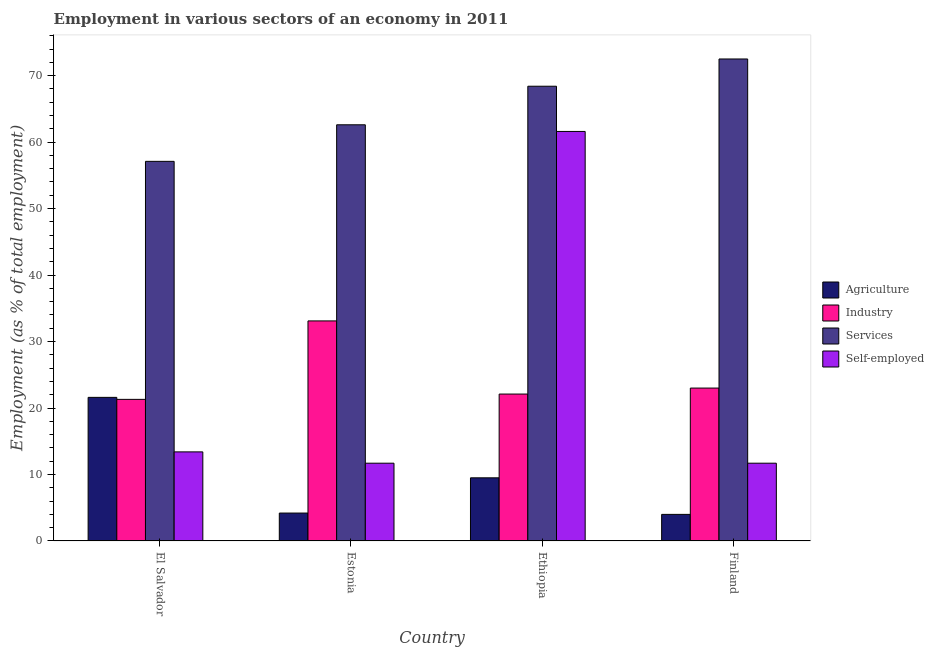How many different coloured bars are there?
Give a very brief answer. 4. How many groups of bars are there?
Provide a short and direct response. 4. Are the number of bars per tick equal to the number of legend labels?
Your answer should be compact. Yes. How many bars are there on the 3rd tick from the left?
Your answer should be very brief. 4. How many bars are there on the 2nd tick from the right?
Give a very brief answer. 4. What is the label of the 2nd group of bars from the left?
Offer a terse response. Estonia. In how many cases, is the number of bars for a given country not equal to the number of legend labels?
Your answer should be compact. 0. What is the percentage of workers in industry in El Salvador?
Provide a short and direct response. 21.3. Across all countries, what is the maximum percentage of workers in industry?
Give a very brief answer. 33.1. Across all countries, what is the minimum percentage of workers in industry?
Offer a very short reply. 21.3. In which country was the percentage of workers in services minimum?
Your response must be concise. El Salvador. What is the total percentage of workers in agriculture in the graph?
Ensure brevity in your answer.  39.3. What is the difference between the percentage of workers in industry in El Salvador and that in Estonia?
Give a very brief answer. -11.8. What is the difference between the percentage of workers in industry in El Salvador and the percentage of workers in services in Ethiopia?
Offer a terse response. -47.1. What is the average percentage of self employed workers per country?
Provide a short and direct response. 24.6. What is the difference between the percentage of workers in services and percentage of workers in agriculture in El Salvador?
Your answer should be very brief. 35.5. In how many countries, is the percentage of workers in agriculture greater than 18 %?
Provide a succinct answer. 1. What is the ratio of the percentage of self employed workers in Ethiopia to that in Finland?
Offer a terse response. 5.26. Is the percentage of workers in industry in El Salvador less than that in Finland?
Your response must be concise. Yes. What is the difference between the highest and the second highest percentage of workers in industry?
Offer a very short reply. 10.1. What is the difference between the highest and the lowest percentage of workers in agriculture?
Offer a terse response. 17.6. What does the 3rd bar from the left in Estonia represents?
Provide a succinct answer. Services. What does the 2nd bar from the right in Estonia represents?
Offer a terse response. Services. Are all the bars in the graph horizontal?
Give a very brief answer. No. What is the difference between two consecutive major ticks on the Y-axis?
Make the answer very short. 10. Are the values on the major ticks of Y-axis written in scientific E-notation?
Offer a very short reply. No. Does the graph contain any zero values?
Make the answer very short. No. Does the graph contain grids?
Offer a terse response. No. Where does the legend appear in the graph?
Ensure brevity in your answer.  Center right. What is the title of the graph?
Your answer should be compact. Employment in various sectors of an economy in 2011. Does "Burnt food" appear as one of the legend labels in the graph?
Keep it short and to the point. No. What is the label or title of the X-axis?
Your answer should be very brief. Country. What is the label or title of the Y-axis?
Your answer should be very brief. Employment (as % of total employment). What is the Employment (as % of total employment) in Agriculture in El Salvador?
Give a very brief answer. 21.6. What is the Employment (as % of total employment) of Industry in El Salvador?
Your response must be concise. 21.3. What is the Employment (as % of total employment) in Services in El Salvador?
Offer a very short reply. 57.1. What is the Employment (as % of total employment) of Self-employed in El Salvador?
Ensure brevity in your answer.  13.4. What is the Employment (as % of total employment) in Agriculture in Estonia?
Your answer should be compact. 4.2. What is the Employment (as % of total employment) in Industry in Estonia?
Your answer should be very brief. 33.1. What is the Employment (as % of total employment) of Services in Estonia?
Make the answer very short. 62.6. What is the Employment (as % of total employment) in Self-employed in Estonia?
Provide a succinct answer. 11.7. What is the Employment (as % of total employment) of Industry in Ethiopia?
Provide a succinct answer. 22.1. What is the Employment (as % of total employment) of Services in Ethiopia?
Your answer should be compact. 68.4. What is the Employment (as % of total employment) in Self-employed in Ethiopia?
Offer a very short reply. 61.6. What is the Employment (as % of total employment) in Agriculture in Finland?
Ensure brevity in your answer.  4. What is the Employment (as % of total employment) in Industry in Finland?
Ensure brevity in your answer.  23. What is the Employment (as % of total employment) in Services in Finland?
Offer a terse response. 72.5. What is the Employment (as % of total employment) of Self-employed in Finland?
Offer a terse response. 11.7. Across all countries, what is the maximum Employment (as % of total employment) of Agriculture?
Offer a terse response. 21.6. Across all countries, what is the maximum Employment (as % of total employment) in Industry?
Offer a terse response. 33.1. Across all countries, what is the maximum Employment (as % of total employment) of Services?
Offer a terse response. 72.5. Across all countries, what is the maximum Employment (as % of total employment) of Self-employed?
Offer a terse response. 61.6. Across all countries, what is the minimum Employment (as % of total employment) of Agriculture?
Provide a short and direct response. 4. Across all countries, what is the minimum Employment (as % of total employment) in Industry?
Provide a short and direct response. 21.3. Across all countries, what is the minimum Employment (as % of total employment) of Services?
Your answer should be compact. 57.1. Across all countries, what is the minimum Employment (as % of total employment) of Self-employed?
Ensure brevity in your answer.  11.7. What is the total Employment (as % of total employment) of Agriculture in the graph?
Ensure brevity in your answer.  39.3. What is the total Employment (as % of total employment) of Industry in the graph?
Offer a terse response. 99.5. What is the total Employment (as % of total employment) of Services in the graph?
Provide a short and direct response. 260.6. What is the total Employment (as % of total employment) in Self-employed in the graph?
Your answer should be compact. 98.4. What is the difference between the Employment (as % of total employment) in Services in El Salvador and that in Estonia?
Your response must be concise. -5.5. What is the difference between the Employment (as % of total employment) of Self-employed in El Salvador and that in Estonia?
Provide a succinct answer. 1.7. What is the difference between the Employment (as % of total employment) of Self-employed in El Salvador and that in Ethiopia?
Offer a terse response. -48.2. What is the difference between the Employment (as % of total employment) of Agriculture in El Salvador and that in Finland?
Make the answer very short. 17.6. What is the difference between the Employment (as % of total employment) of Industry in El Salvador and that in Finland?
Your answer should be compact. -1.7. What is the difference between the Employment (as % of total employment) in Services in El Salvador and that in Finland?
Make the answer very short. -15.4. What is the difference between the Employment (as % of total employment) in Services in Estonia and that in Ethiopia?
Keep it short and to the point. -5.8. What is the difference between the Employment (as % of total employment) of Self-employed in Estonia and that in Ethiopia?
Give a very brief answer. -49.9. What is the difference between the Employment (as % of total employment) of Agriculture in Estonia and that in Finland?
Provide a succinct answer. 0.2. What is the difference between the Employment (as % of total employment) in Industry in Estonia and that in Finland?
Your answer should be very brief. 10.1. What is the difference between the Employment (as % of total employment) of Agriculture in Ethiopia and that in Finland?
Keep it short and to the point. 5.5. What is the difference between the Employment (as % of total employment) in Industry in Ethiopia and that in Finland?
Your answer should be compact. -0.9. What is the difference between the Employment (as % of total employment) in Services in Ethiopia and that in Finland?
Your response must be concise. -4.1. What is the difference between the Employment (as % of total employment) of Self-employed in Ethiopia and that in Finland?
Give a very brief answer. 49.9. What is the difference between the Employment (as % of total employment) of Agriculture in El Salvador and the Employment (as % of total employment) of Services in Estonia?
Provide a short and direct response. -41. What is the difference between the Employment (as % of total employment) of Industry in El Salvador and the Employment (as % of total employment) of Services in Estonia?
Provide a short and direct response. -41.3. What is the difference between the Employment (as % of total employment) in Industry in El Salvador and the Employment (as % of total employment) in Self-employed in Estonia?
Give a very brief answer. 9.6. What is the difference between the Employment (as % of total employment) in Services in El Salvador and the Employment (as % of total employment) in Self-employed in Estonia?
Ensure brevity in your answer.  45.4. What is the difference between the Employment (as % of total employment) of Agriculture in El Salvador and the Employment (as % of total employment) of Industry in Ethiopia?
Ensure brevity in your answer.  -0.5. What is the difference between the Employment (as % of total employment) in Agriculture in El Salvador and the Employment (as % of total employment) in Services in Ethiopia?
Offer a very short reply. -46.8. What is the difference between the Employment (as % of total employment) in Industry in El Salvador and the Employment (as % of total employment) in Services in Ethiopia?
Your response must be concise. -47.1. What is the difference between the Employment (as % of total employment) of Industry in El Salvador and the Employment (as % of total employment) of Self-employed in Ethiopia?
Offer a very short reply. -40.3. What is the difference between the Employment (as % of total employment) in Services in El Salvador and the Employment (as % of total employment) in Self-employed in Ethiopia?
Ensure brevity in your answer.  -4.5. What is the difference between the Employment (as % of total employment) of Agriculture in El Salvador and the Employment (as % of total employment) of Services in Finland?
Keep it short and to the point. -50.9. What is the difference between the Employment (as % of total employment) in Industry in El Salvador and the Employment (as % of total employment) in Services in Finland?
Provide a succinct answer. -51.2. What is the difference between the Employment (as % of total employment) of Industry in El Salvador and the Employment (as % of total employment) of Self-employed in Finland?
Ensure brevity in your answer.  9.6. What is the difference between the Employment (as % of total employment) in Services in El Salvador and the Employment (as % of total employment) in Self-employed in Finland?
Provide a short and direct response. 45.4. What is the difference between the Employment (as % of total employment) of Agriculture in Estonia and the Employment (as % of total employment) of Industry in Ethiopia?
Keep it short and to the point. -17.9. What is the difference between the Employment (as % of total employment) in Agriculture in Estonia and the Employment (as % of total employment) in Services in Ethiopia?
Make the answer very short. -64.2. What is the difference between the Employment (as % of total employment) of Agriculture in Estonia and the Employment (as % of total employment) of Self-employed in Ethiopia?
Ensure brevity in your answer.  -57.4. What is the difference between the Employment (as % of total employment) in Industry in Estonia and the Employment (as % of total employment) in Services in Ethiopia?
Your answer should be very brief. -35.3. What is the difference between the Employment (as % of total employment) of Industry in Estonia and the Employment (as % of total employment) of Self-employed in Ethiopia?
Your answer should be compact. -28.5. What is the difference between the Employment (as % of total employment) in Agriculture in Estonia and the Employment (as % of total employment) in Industry in Finland?
Keep it short and to the point. -18.8. What is the difference between the Employment (as % of total employment) of Agriculture in Estonia and the Employment (as % of total employment) of Services in Finland?
Provide a short and direct response. -68.3. What is the difference between the Employment (as % of total employment) in Agriculture in Estonia and the Employment (as % of total employment) in Self-employed in Finland?
Provide a succinct answer. -7.5. What is the difference between the Employment (as % of total employment) of Industry in Estonia and the Employment (as % of total employment) of Services in Finland?
Your answer should be compact. -39.4. What is the difference between the Employment (as % of total employment) in Industry in Estonia and the Employment (as % of total employment) in Self-employed in Finland?
Ensure brevity in your answer.  21.4. What is the difference between the Employment (as % of total employment) in Services in Estonia and the Employment (as % of total employment) in Self-employed in Finland?
Offer a terse response. 50.9. What is the difference between the Employment (as % of total employment) in Agriculture in Ethiopia and the Employment (as % of total employment) in Services in Finland?
Ensure brevity in your answer.  -63. What is the difference between the Employment (as % of total employment) in Agriculture in Ethiopia and the Employment (as % of total employment) in Self-employed in Finland?
Make the answer very short. -2.2. What is the difference between the Employment (as % of total employment) in Industry in Ethiopia and the Employment (as % of total employment) in Services in Finland?
Offer a very short reply. -50.4. What is the difference between the Employment (as % of total employment) in Industry in Ethiopia and the Employment (as % of total employment) in Self-employed in Finland?
Keep it short and to the point. 10.4. What is the difference between the Employment (as % of total employment) of Services in Ethiopia and the Employment (as % of total employment) of Self-employed in Finland?
Offer a terse response. 56.7. What is the average Employment (as % of total employment) of Agriculture per country?
Your response must be concise. 9.82. What is the average Employment (as % of total employment) in Industry per country?
Give a very brief answer. 24.88. What is the average Employment (as % of total employment) of Services per country?
Provide a succinct answer. 65.15. What is the average Employment (as % of total employment) of Self-employed per country?
Make the answer very short. 24.6. What is the difference between the Employment (as % of total employment) of Agriculture and Employment (as % of total employment) of Industry in El Salvador?
Provide a short and direct response. 0.3. What is the difference between the Employment (as % of total employment) of Agriculture and Employment (as % of total employment) of Services in El Salvador?
Provide a succinct answer. -35.5. What is the difference between the Employment (as % of total employment) in Industry and Employment (as % of total employment) in Services in El Salvador?
Your answer should be very brief. -35.8. What is the difference between the Employment (as % of total employment) of Services and Employment (as % of total employment) of Self-employed in El Salvador?
Provide a succinct answer. 43.7. What is the difference between the Employment (as % of total employment) in Agriculture and Employment (as % of total employment) in Industry in Estonia?
Your answer should be compact. -28.9. What is the difference between the Employment (as % of total employment) in Agriculture and Employment (as % of total employment) in Services in Estonia?
Keep it short and to the point. -58.4. What is the difference between the Employment (as % of total employment) in Agriculture and Employment (as % of total employment) in Self-employed in Estonia?
Your answer should be compact. -7.5. What is the difference between the Employment (as % of total employment) in Industry and Employment (as % of total employment) in Services in Estonia?
Provide a succinct answer. -29.5. What is the difference between the Employment (as % of total employment) of Industry and Employment (as % of total employment) of Self-employed in Estonia?
Offer a very short reply. 21.4. What is the difference between the Employment (as % of total employment) of Services and Employment (as % of total employment) of Self-employed in Estonia?
Your answer should be compact. 50.9. What is the difference between the Employment (as % of total employment) in Agriculture and Employment (as % of total employment) in Services in Ethiopia?
Keep it short and to the point. -58.9. What is the difference between the Employment (as % of total employment) in Agriculture and Employment (as % of total employment) in Self-employed in Ethiopia?
Provide a succinct answer. -52.1. What is the difference between the Employment (as % of total employment) in Industry and Employment (as % of total employment) in Services in Ethiopia?
Keep it short and to the point. -46.3. What is the difference between the Employment (as % of total employment) of Industry and Employment (as % of total employment) of Self-employed in Ethiopia?
Your answer should be very brief. -39.5. What is the difference between the Employment (as % of total employment) of Services and Employment (as % of total employment) of Self-employed in Ethiopia?
Your response must be concise. 6.8. What is the difference between the Employment (as % of total employment) of Agriculture and Employment (as % of total employment) of Industry in Finland?
Your answer should be very brief. -19. What is the difference between the Employment (as % of total employment) of Agriculture and Employment (as % of total employment) of Services in Finland?
Provide a short and direct response. -68.5. What is the difference between the Employment (as % of total employment) of Agriculture and Employment (as % of total employment) of Self-employed in Finland?
Provide a short and direct response. -7.7. What is the difference between the Employment (as % of total employment) in Industry and Employment (as % of total employment) in Services in Finland?
Your answer should be compact. -49.5. What is the difference between the Employment (as % of total employment) in Industry and Employment (as % of total employment) in Self-employed in Finland?
Make the answer very short. 11.3. What is the difference between the Employment (as % of total employment) in Services and Employment (as % of total employment) in Self-employed in Finland?
Ensure brevity in your answer.  60.8. What is the ratio of the Employment (as % of total employment) of Agriculture in El Salvador to that in Estonia?
Ensure brevity in your answer.  5.14. What is the ratio of the Employment (as % of total employment) of Industry in El Salvador to that in Estonia?
Offer a very short reply. 0.64. What is the ratio of the Employment (as % of total employment) of Services in El Salvador to that in Estonia?
Offer a terse response. 0.91. What is the ratio of the Employment (as % of total employment) of Self-employed in El Salvador to that in Estonia?
Provide a succinct answer. 1.15. What is the ratio of the Employment (as % of total employment) in Agriculture in El Salvador to that in Ethiopia?
Ensure brevity in your answer.  2.27. What is the ratio of the Employment (as % of total employment) of Industry in El Salvador to that in Ethiopia?
Make the answer very short. 0.96. What is the ratio of the Employment (as % of total employment) of Services in El Salvador to that in Ethiopia?
Ensure brevity in your answer.  0.83. What is the ratio of the Employment (as % of total employment) in Self-employed in El Salvador to that in Ethiopia?
Your answer should be compact. 0.22. What is the ratio of the Employment (as % of total employment) in Agriculture in El Salvador to that in Finland?
Make the answer very short. 5.4. What is the ratio of the Employment (as % of total employment) in Industry in El Salvador to that in Finland?
Ensure brevity in your answer.  0.93. What is the ratio of the Employment (as % of total employment) in Services in El Salvador to that in Finland?
Make the answer very short. 0.79. What is the ratio of the Employment (as % of total employment) in Self-employed in El Salvador to that in Finland?
Your answer should be compact. 1.15. What is the ratio of the Employment (as % of total employment) of Agriculture in Estonia to that in Ethiopia?
Your answer should be compact. 0.44. What is the ratio of the Employment (as % of total employment) of Industry in Estonia to that in Ethiopia?
Provide a succinct answer. 1.5. What is the ratio of the Employment (as % of total employment) of Services in Estonia to that in Ethiopia?
Provide a succinct answer. 0.92. What is the ratio of the Employment (as % of total employment) in Self-employed in Estonia to that in Ethiopia?
Provide a short and direct response. 0.19. What is the ratio of the Employment (as % of total employment) of Industry in Estonia to that in Finland?
Give a very brief answer. 1.44. What is the ratio of the Employment (as % of total employment) of Services in Estonia to that in Finland?
Your response must be concise. 0.86. What is the ratio of the Employment (as % of total employment) in Agriculture in Ethiopia to that in Finland?
Offer a very short reply. 2.38. What is the ratio of the Employment (as % of total employment) in Industry in Ethiopia to that in Finland?
Offer a very short reply. 0.96. What is the ratio of the Employment (as % of total employment) in Services in Ethiopia to that in Finland?
Your response must be concise. 0.94. What is the ratio of the Employment (as % of total employment) of Self-employed in Ethiopia to that in Finland?
Keep it short and to the point. 5.26. What is the difference between the highest and the second highest Employment (as % of total employment) of Self-employed?
Offer a terse response. 48.2. What is the difference between the highest and the lowest Employment (as % of total employment) in Agriculture?
Your response must be concise. 17.6. What is the difference between the highest and the lowest Employment (as % of total employment) of Services?
Keep it short and to the point. 15.4. What is the difference between the highest and the lowest Employment (as % of total employment) in Self-employed?
Your response must be concise. 49.9. 